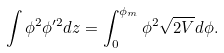<formula> <loc_0><loc_0><loc_500><loc_500>\int \phi ^ { 2 } \phi ^ { \prime 2 } d z = \int _ { 0 } ^ { \phi _ { m } } \phi ^ { 2 } \sqrt { 2 V } d \phi .</formula> 